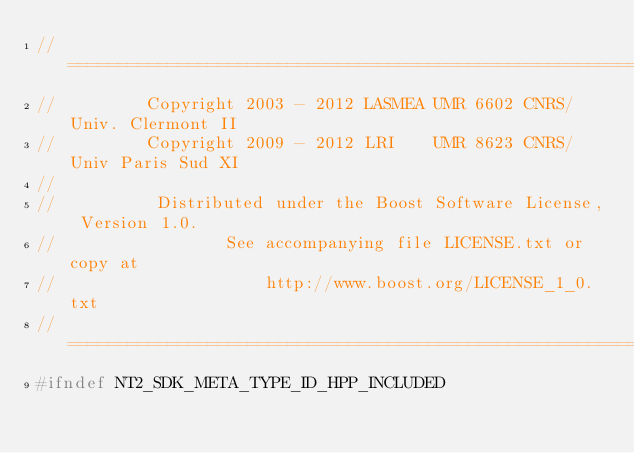Convert code to text. <code><loc_0><loc_0><loc_500><loc_500><_C++_>//==============================================================================
//         Copyright 2003 - 2012 LASMEA UMR 6602 CNRS/Univ. Clermont II
//         Copyright 2009 - 2012 LRI    UMR 8623 CNRS/Univ Paris Sud XI
//
//          Distributed under the Boost Software License, Version 1.0.
//                 See accompanying file LICENSE.txt or copy at
//                     http://www.boost.org/LICENSE_1_0.txt
//==============================================================================
#ifndef NT2_SDK_META_TYPE_ID_HPP_INCLUDED</code> 